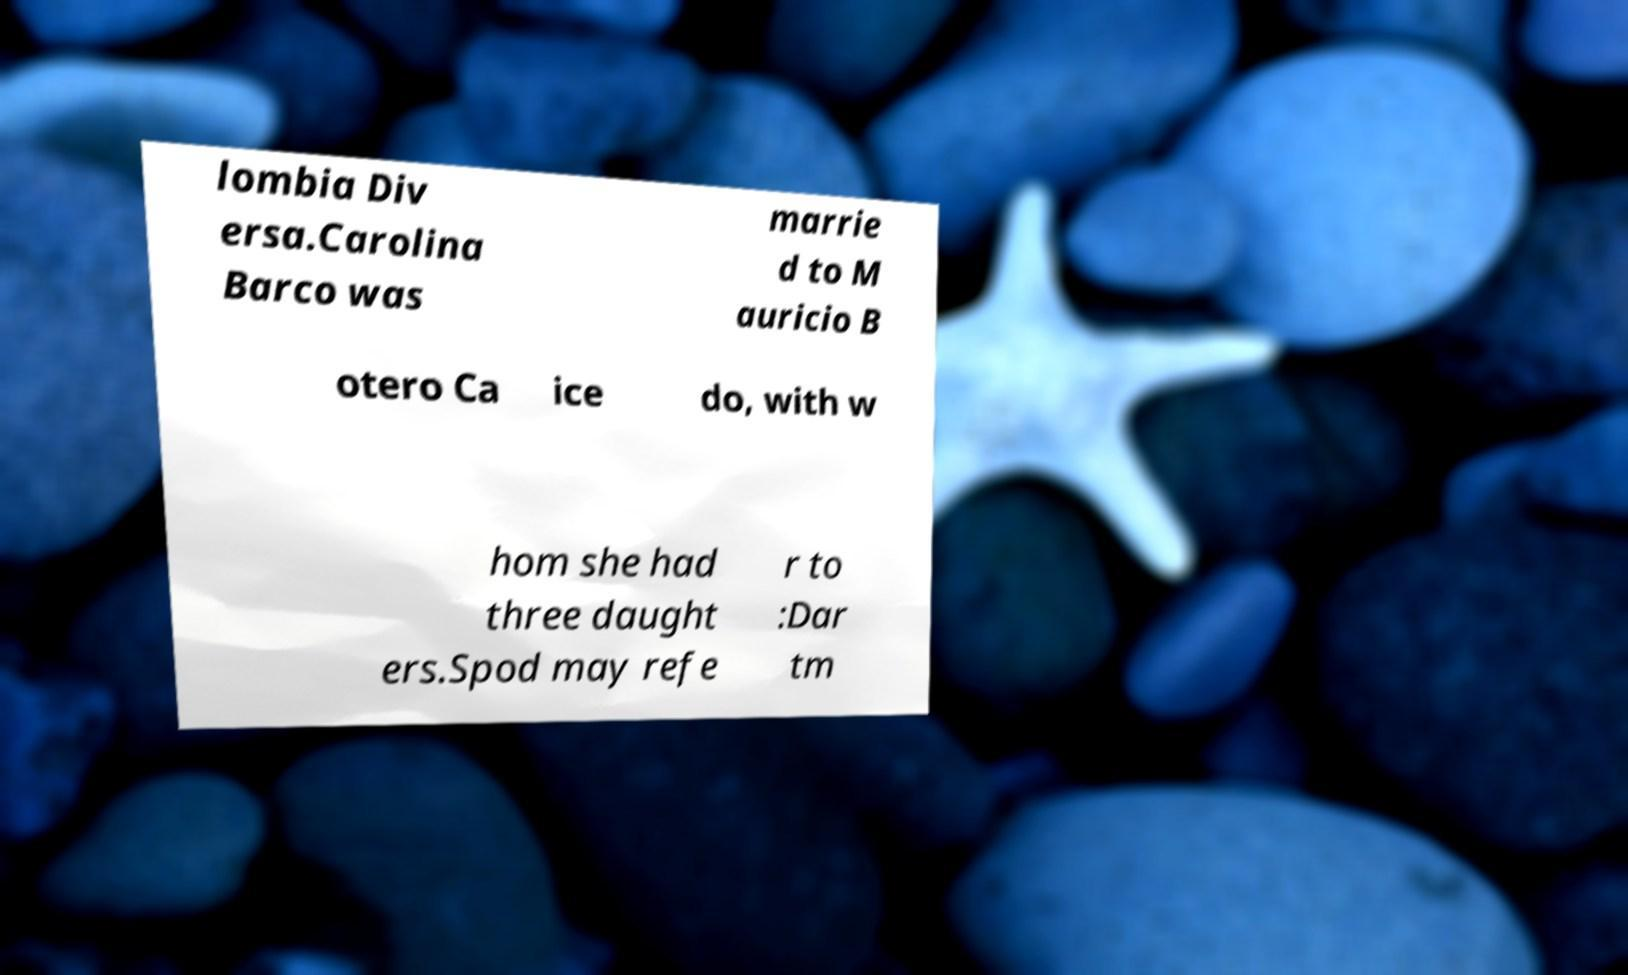I need the written content from this picture converted into text. Can you do that? lombia Div ersa.Carolina Barco was marrie d to M auricio B otero Ca ice do, with w hom she had three daught ers.Spod may refe r to :Dar tm 